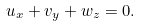Convert formula to latex. <formula><loc_0><loc_0><loc_500><loc_500>u _ { x } + v _ { y } + w _ { z } = 0 .</formula> 